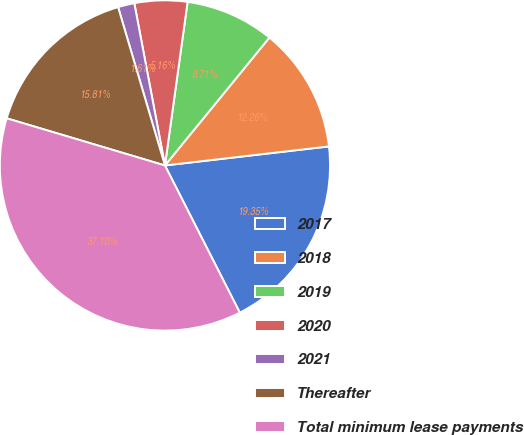Convert chart to OTSL. <chart><loc_0><loc_0><loc_500><loc_500><pie_chart><fcel>2017<fcel>2018<fcel>2019<fcel>2020<fcel>2021<fcel>Thereafter<fcel>Total minimum lease payments<nl><fcel>19.35%<fcel>12.26%<fcel>8.71%<fcel>5.16%<fcel>1.61%<fcel>15.81%<fcel>37.1%<nl></chart> 